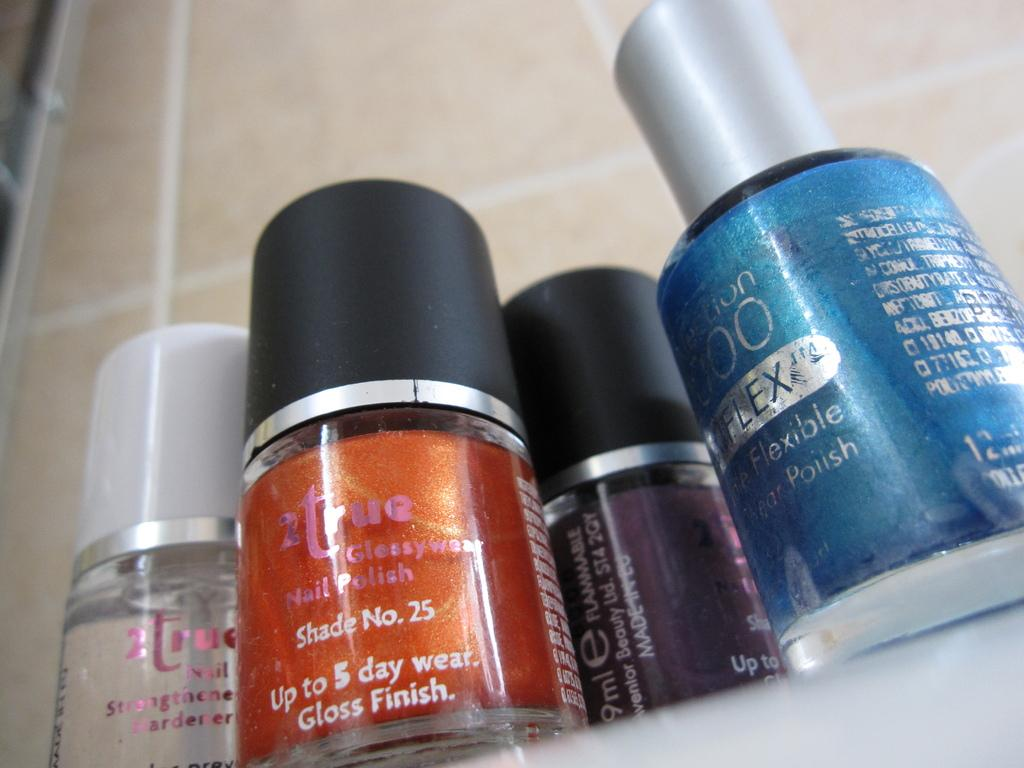<image>
Create a compact narrative representing the image presented. for bottles of 5 day nail polishs in different colors 